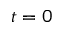<formula> <loc_0><loc_0><loc_500><loc_500>t = 0</formula> 